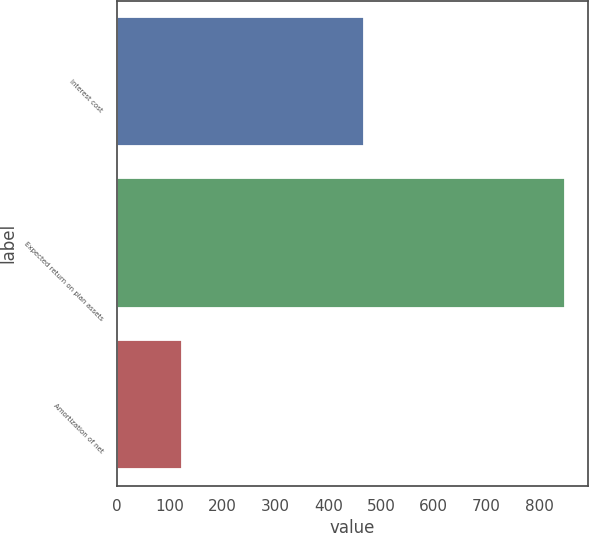<chart> <loc_0><loc_0><loc_500><loc_500><bar_chart><fcel>Interest cost<fcel>Expected return on plan assets<fcel>Amortization of net<nl><fcel>468<fcel>849<fcel>123<nl></chart> 